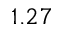<formula> <loc_0><loc_0><loc_500><loc_500>1 . 2 7</formula> 